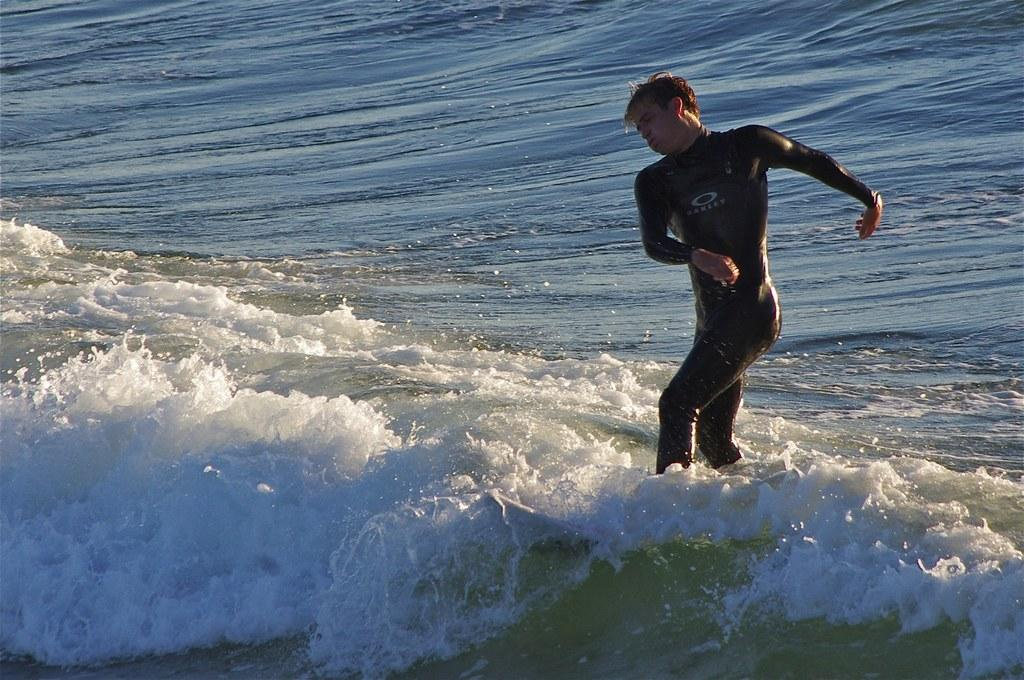Who is present in the image? There is a man in the image. What is the man doing in the image? The man is standing in the water. What is the man wearing in the image? The man is wearing a swimming costume. What type of milk is the man drinking in the image? There is no milk present in the image; the man is standing in the water and wearing a swimming costume. 